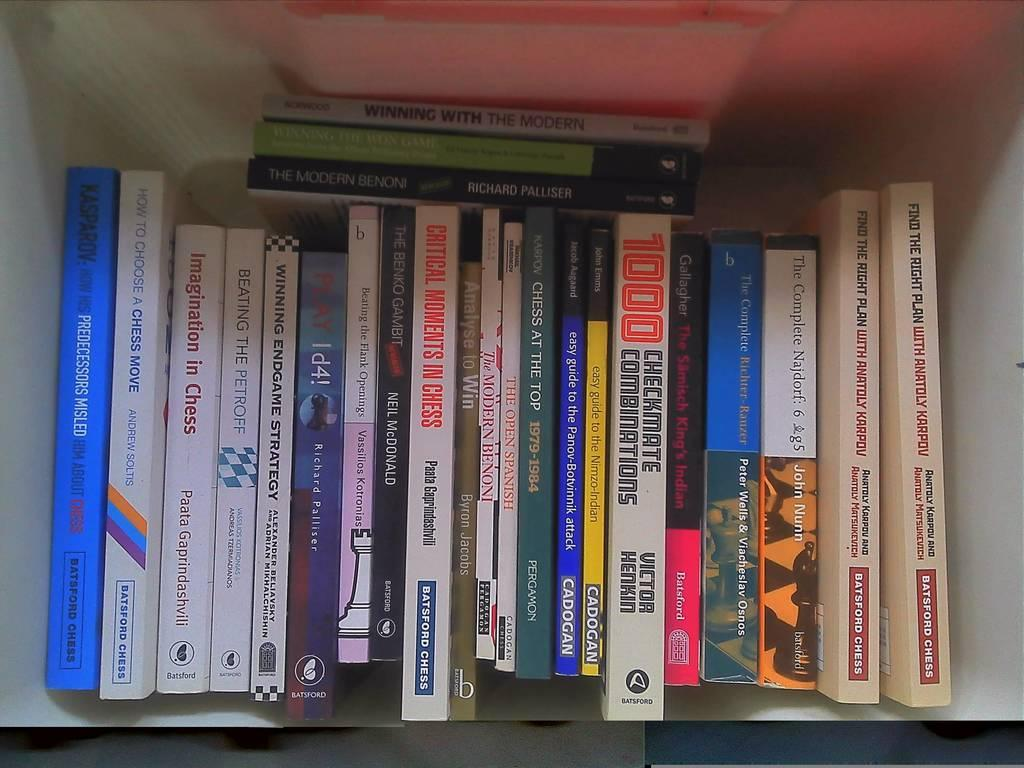<image>
Relay a brief, clear account of the picture shown. A stack of books on a shelf concerning the game of Chess 